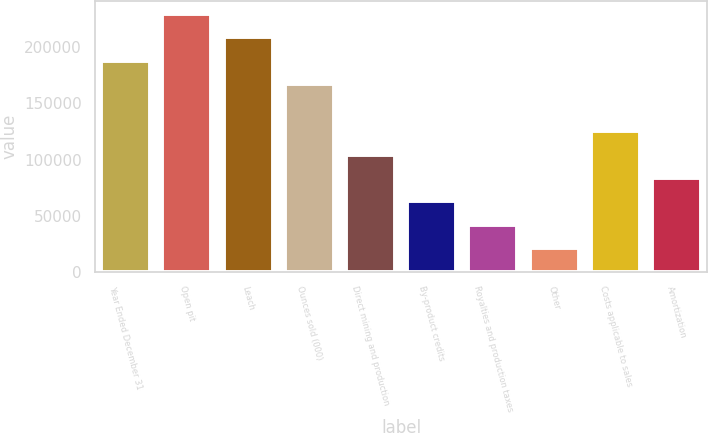Convert chart. <chart><loc_0><loc_0><loc_500><loc_500><bar_chart><fcel>Year Ended December 31<fcel>Open pit<fcel>Leach<fcel>Ounces sold (000)<fcel>Direct mining and production<fcel>By-product credits<fcel>Royalties and production taxes<fcel>Other<fcel>Costs applicable to sales<fcel>Amortization<nl><fcel>187984<fcel>229758<fcel>208871<fcel>167098<fcel>104438<fcel>62665.5<fcel>41779<fcel>20892.5<fcel>125325<fcel>83552<nl></chart> 